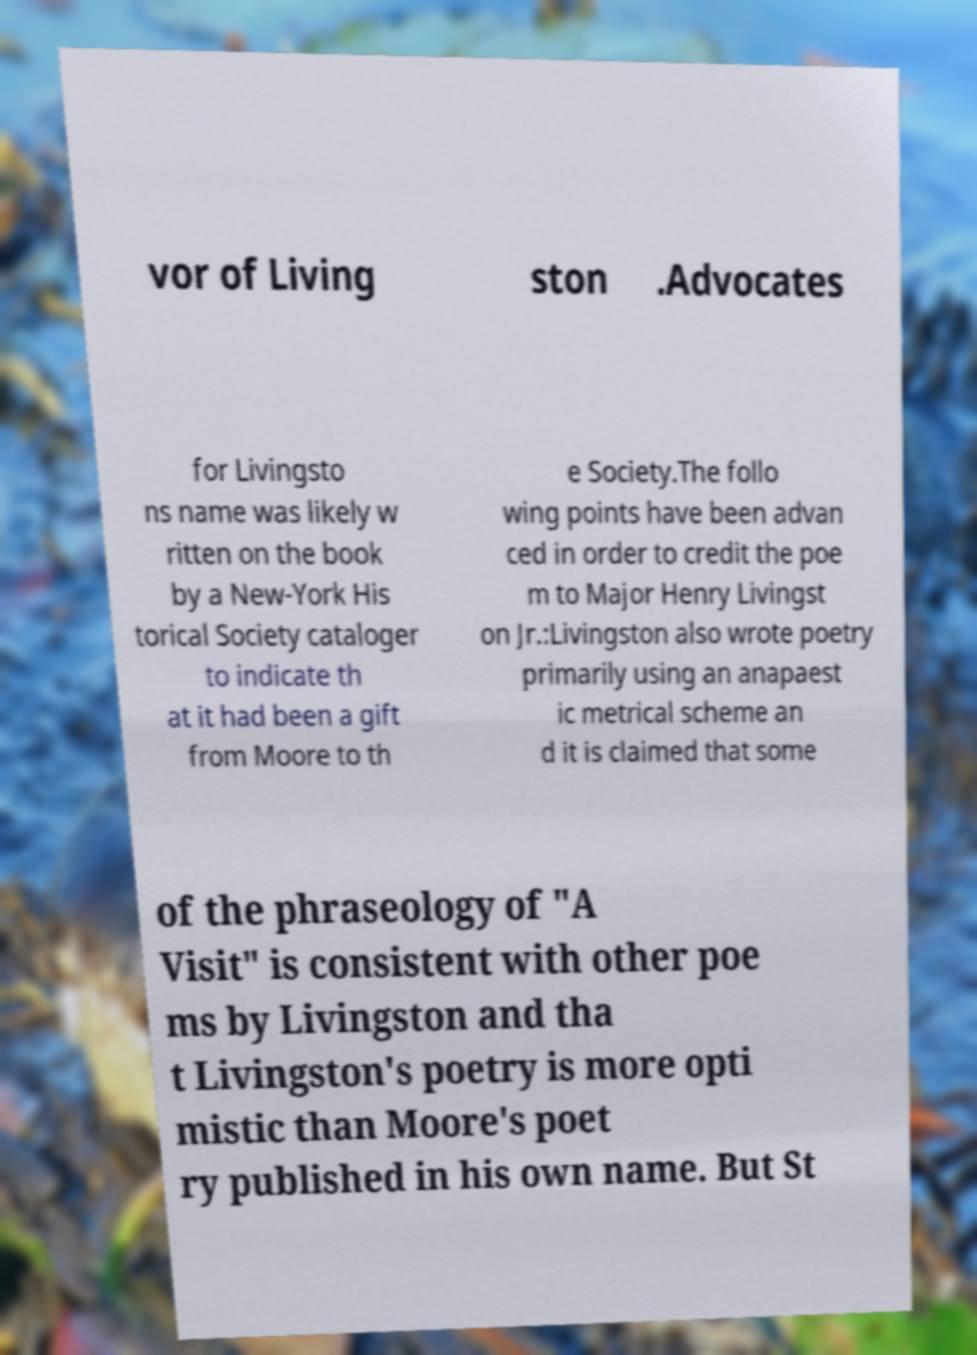Please read and relay the text visible in this image. What does it say? vor of Living ston .Advocates for Livingsto ns name was likely w ritten on the book by a New-York His torical Society cataloger to indicate th at it had been a gift from Moore to th e Society.The follo wing points have been advan ced in order to credit the poe m to Major Henry Livingst on Jr.:Livingston also wrote poetry primarily using an anapaest ic metrical scheme an d it is claimed that some of the phraseology of "A Visit" is consistent with other poe ms by Livingston and tha t Livingston's poetry is more opti mistic than Moore's poet ry published in his own name. But St 